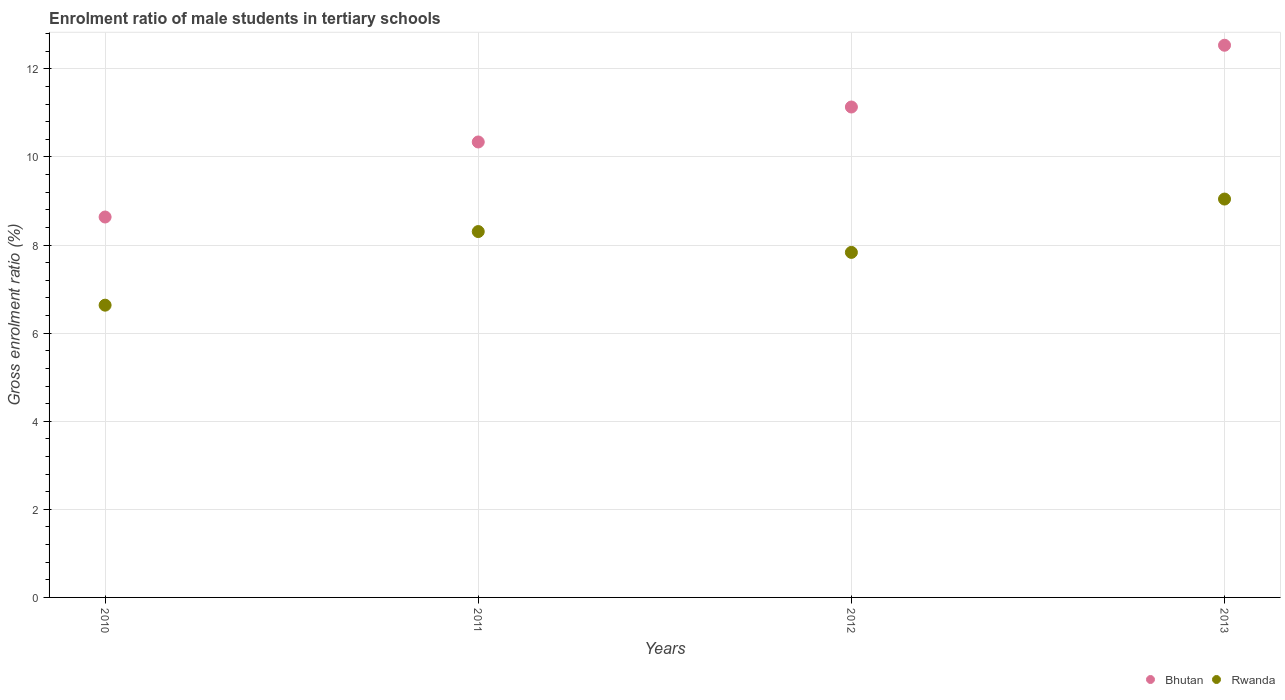How many different coloured dotlines are there?
Offer a terse response. 2. Is the number of dotlines equal to the number of legend labels?
Provide a succinct answer. Yes. What is the enrolment ratio of male students in tertiary schools in Bhutan in 2012?
Offer a very short reply. 11.13. Across all years, what is the maximum enrolment ratio of male students in tertiary schools in Rwanda?
Ensure brevity in your answer.  9.04. Across all years, what is the minimum enrolment ratio of male students in tertiary schools in Bhutan?
Keep it short and to the point. 8.64. In which year was the enrolment ratio of male students in tertiary schools in Bhutan maximum?
Your answer should be compact. 2013. In which year was the enrolment ratio of male students in tertiary schools in Bhutan minimum?
Offer a very short reply. 2010. What is the total enrolment ratio of male students in tertiary schools in Rwanda in the graph?
Provide a short and direct response. 31.82. What is the difference between the enrolment ratio of male students in tertiary schools in Rwanda in 2010 and that in 2011?
Offer a terse response. -1.67. What is the difference between the enrolment ratio of male students in tertiary schools in Bhutan in 2011 and the enrolment ratio of male students in tertiary schools in Rwanda in 2010?
Your response must be concise. 3.7. What is the average enrolment ratio of male students in tertiary schools in Bhutan per year?
Offer a very short reply. 10.66. In the year 2012, what is the difference between the enrolment ratio of male students in tertiary schools in Bhutan and enrolment ratio of male students in tertiary schools in Rwanda?
Provide a succinct answer. 3.3. In how many years, is the enrolment ratio of male students in tertiary schools in Rwanda greater than 12 %?
Give a very brief answer. 0. What is the ratio of the enrolment ratio of male students in tertiary schools in Bhutan in 2012 to that in 2013?
Your answer should be compact. 0.89. Is the enrolment ratio of male students in tertiary schools in Rwanda in 2010 less than that in 2013?
Provide a short and direct response. Yes. What is the difference between the highest and the second highest enrolment ratio of male students in tertiary schools in Rwanda?
Your answer should be very brief. 0.74. What is the difference between the highest and the lowest enrolment ratio of male students in tertiary schools in Rwanda?
Make the answer very short. 2.41. Does the enrolment ratio of male students in tertiary schools in Bhutan monotonically increase over the years?
Provide a short and direct response. Yes. Is the enrolment ratio of male students in tertiary schools in Rwanda strictly greater than the enrolment ratio of male students in tertiary schools in Bhutan over the years?
Provide a succinct answer. No. Is the enrolment ratio of male students in tertiary schools in Rwanda strictly less than the enrolment ratio of male students in tertiary schools in Bhutan over the years?
Offer a very short reply. Yes. How many dotlines are there?
Make the answer very short. 2. How many years are there in the graph?
Provide a succinct answer. 4. Does the graph contain any zero values?
Your answer should be compact. No. Where does the legend appear in the graph?
Give a very brief answer. Bottom right. What is the title of the graph?
Make the answer very short. Enrolment ratio of male students in tertiary schools. Does "Arab World" appear as one of the legend labels in the graph?
Offer a very short reply. No. What is the label or title of the Y-axis?
Offer a terse response. Gross enrolment ratio (%). What is the Gross enrolment ratio (%) in Bhutan in 2010?
Your response must be concise. 8.64. What is the Gross enrolment ratio (%) of Rwanda in 2010?
Make the answer very short. 6.64. What is the Gross enrolment ratio (%) in Bhutan in 2011?
Your answer should be compact. 10.34. What is the Gross enrolment ratio (%) of Rwanda in 2011?
Give a very brief answer. 8.31. What is the Gross enrolment ratio (%) in Bhutan in 2012?
Your answer should be very brief. 11.13. What is the Gross enrolment ratio (%) in Rwanda in 2012?
Your answer should be very brief. 7.83. What is the Gross enrolment ratio (%) of Bhutan in 2013?
Make the answer very short. 12.54. What is the Gross enrolment ratio (%) of Rwanda in 2013?
Offer a very short reply. 9.04. Across all years, what is the maximum Gross enrolment ratio (%) in Bhutan?
Provide a short and direct response. 12.54. Across all years, what is the maximum Gross enrolment ratio (%) of Rwanda?
Give a very brief answer. 9.04. Across all years, what is the minimum Gross enrolment ratio (%) in Bhutan?
Your answer should be compact. 8.64. Across all years, what is the minimum Gross enrolment ratio (%) in Rwanda?
Make the answer very short. 6.64. What is the total Gross enrolment ratio (%) in Bhutan in the graph?
Offer a terse response. 42.65. What is the total Gross enrolment ratio (%) in Rwanda in the graph?
Your answer should be very brief. 31.82. What is the difference between the Gross enrolment ratio (%) of Bhutan in 2010 and that in 2011?
Your answer should be compact. -1.7. What is the difference between the Gross enrolment ratio (%) of Rwanda in 2010 and that in 2011?
Provide a succinct answer. -1.67. What is the difference between the Gross enrolment ratio (%) of Bhutan in 2010 and that in 2012?
Provide a short and direct response. -2.5. What is the difference between the Gross enrolment ratio (%) of Rwanda in 2010 and that in 2012?
Give a very brief answer. -1.2. What is the difference between the Gross enrolment ratio (%) in Bhutan in 2010 and that in 2013?
Make the answer very short. -3.9. What is the difference between the Gross enrolment ratio (%) of Rwanda in 2010 and that in 2013?
Your answer should be compact. -2.41. What is the difference between the Gross enrolment ratio (%) of Bhutan in 2011 and that in 2012?
Make the answer very short. -0.79. What is the difference between the Gross enrolment ratio (%) in Rwanda in 2011 and that in 2012?
Give a very brief answer. 0.47. What is the difference between the Gross enrolment ratio (%) of Bhutan in 2011 and that in 2013?
Offer a very short reply. -2.2. What is the difference between the Gross enrolment ratio (%) of Rwanda in 2011 and that in 2013?
Offer a terse response. -0.74. What is the difference between the Gross enrolment ratio (%) in Bhutan in 2012 and that in 2013?
Your response must be concise. -1.4. What is the difference between the Gross enrolment ratio (%) of Rwanda in 2012 and that in 2013?
Keep it short and to the point. -1.21. What is the difference between the Gross enrolment ratio (%) of Bhutan in 2010 and the Gross enrolment ratio (%) of Rwanda in 2011?
Provide a succinct answer. 0.33. What is the difference between the Gross enrolment ratio (%) in Bhutan in 2010 and the Gross enrolment ratio (%) in Rwanda in 2012?
Keep it short and to the point. 0.8. What is the difference between the Gross enrolment ratio (%) in Bhutan in 2010 and the Gross enrolment ratio (%) in Rwanda in 2013?
Your answer should be compact. -0.41. What is the difference between the Gross enrolment ratio (%) of Bhutan in 2011 and the Gross enrolment ratio (%) of Rwanda in 2012?
Offer a terse response. 2.51. What is the difference between the Gross enrolment ratio (%) in Bhutan in 2011 and the Gross enrolment ratio (%) in Rwanda in 2013?
Offer a terse response. 1.3. What is the difference between the Gross enrolment ratio (%) of Bhutan in 2012 and the Gross enrolment ratio (%) of Rwanda in 2013?
Your answer should be compact. 2.09. What is the average Gross enrolment ratio (%) of Bhutan per year?
Your response must be concise. 10.66. What is the average Gross enrolment ratio (%) in Rwanda per year?
Provide a short and direct response. 7.95. In the year 2010, what is the difference between the Gross enrolment ratio (%) in Bhutan and Gross enrolment ratio (%) in Rwanda?
Ensure brevity in your answer.  2. In the year 2011, what is the difference between the Gross enrolment ratio (%) of Bhutan and Gross enrolment ratio (%) of Rwanda?
Provide a short and direct response. 2.03. In the year 2012, what is the difference between the Gross enrolment ratio (%) in Bhutan and Gross enrolment ratio (%) in Rwanda?
Offer a very short reply. 3.3. In the year 2013, what is the difference between the Gross enrolment ratio (%) in Bhutan and Gross enrolment ratio (%) in Rwanda?
Keep it short and to the point. 3.49. What is the ratio of the Gross enrolment ratio (%) of Bhutan in 2010 to that in 2011?
Provide a short and direct response. 0.84. What is the ratio of the Gross enrolment ratio (%) in Rwanda in 2010 to that in 2011?
Offer a very short reply. 0.8. What is the ratio of the Gross enrolment ratio (%) of Bhutan in 2010 to that in 2012?
Ensure brevity in your answer.  0.78. What is the ratio of the Gross enrolment ratio (%) in Rwanda in 2010 to that in 2012?
Your answer should be very brief. 0.85. What is the ratio of the Gross enrolment ratio (%) of Bhutan in 2010 to that in 2013?
Provide a succinct answer. 0.69. What is the ratio of the Gross enrolment ratio (%) in Rwanda in 2010 to that in 2013?
Offer a terse response. 0.73. What is the ratio of the Gross enrolment ratio (%) of Bhutan in 2011 to that in 2012?
Offer a terse response. 0.93. What is the ratio of the Gross enrolment ratio (%) of Rwanda in 2011 to that in 2012?
Offer a very short reply. 1.06. What is the ratio of the Gross enrolment ratio (%) in Bhutan in 2011 to that in 2013?
Provide a short and direct response. 0.82. What is the ratio of the Gross enrolment ratio (%) of Rwanda in 2011 to that in 2013?
Ensure brevity in your answer.  0.92. What is the ratio of the Gross enrolment ratio (%) of Bhutan in 2012 to that in 2013?
Offer a very short reply. 0.89. What is the ratio of the Gross enrolment ratio (%) of Rwanda in 2012 to that in 2013?
Your response must be concise. 0.87. What is the difference between the highest and the second highest Gross enrolment ratio (%) of Bhutan?
Give a very brief answer. 1.4. What is the difference between the highest and the second highest Gross enrolment ratio (%) of Rwanda?
Ensure brevity in your answer.  0.74. What is the difference between the highest and the lowest Gross enrolment ratio (%) in Bhutan?
Offer a very short reply. 3.9. What is the difference between the highest and the lowest Gross enrolment ratio (%) of Rwanda?
Your answer should be compact. 2.41. 